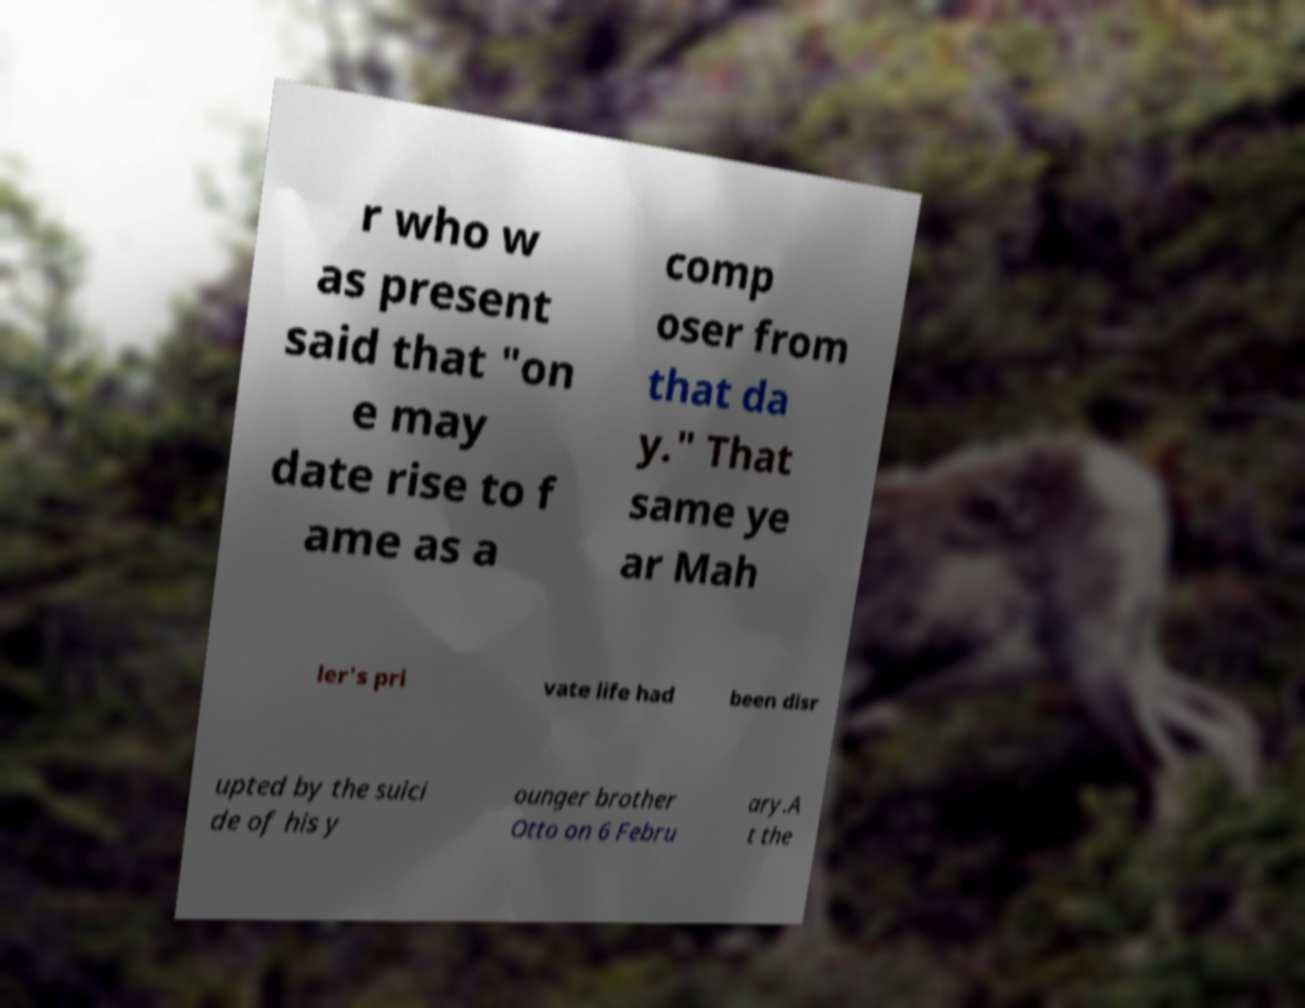For documentation purposes, I need the text within this image transcribed. Could you provide that? r who w as present said that "on e may date rise to f ame as a comp oser from that da y." That same ye ar Mah ler's pri vate life had been disr upted by the suici de of his y ounger brother Otto on 6 Febru ary.A t the 